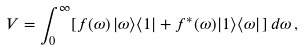Convert formula to latex. <formula><loc_0><loc_0><loc_500><loc_500>V = \int _ { 0 } ^ { \infty } [ f ( \omega ) \, | \omega \rangle \langle 1 | + f ^ { * } ( \omega ) | 1 \rangle \langle \omega | \, ] \, d \omega \, ,</formula> 